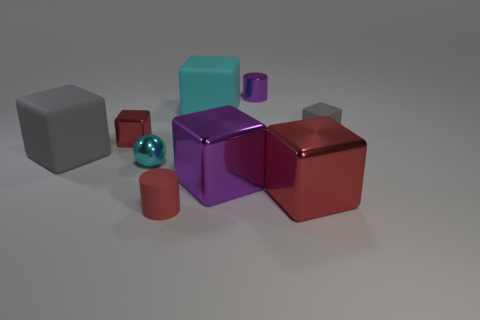Can you infer the possible lighting setup used in this scene? Based on the reflections and shadows in the image, it appears there's a primary light source located above and slightly to the right of the scene, creating distinct but soft shadows on the left sides of the objects. Additionally, there may be ambient light contributing to the overall illumination, as indicated by the lack of extremely dark shadows. 